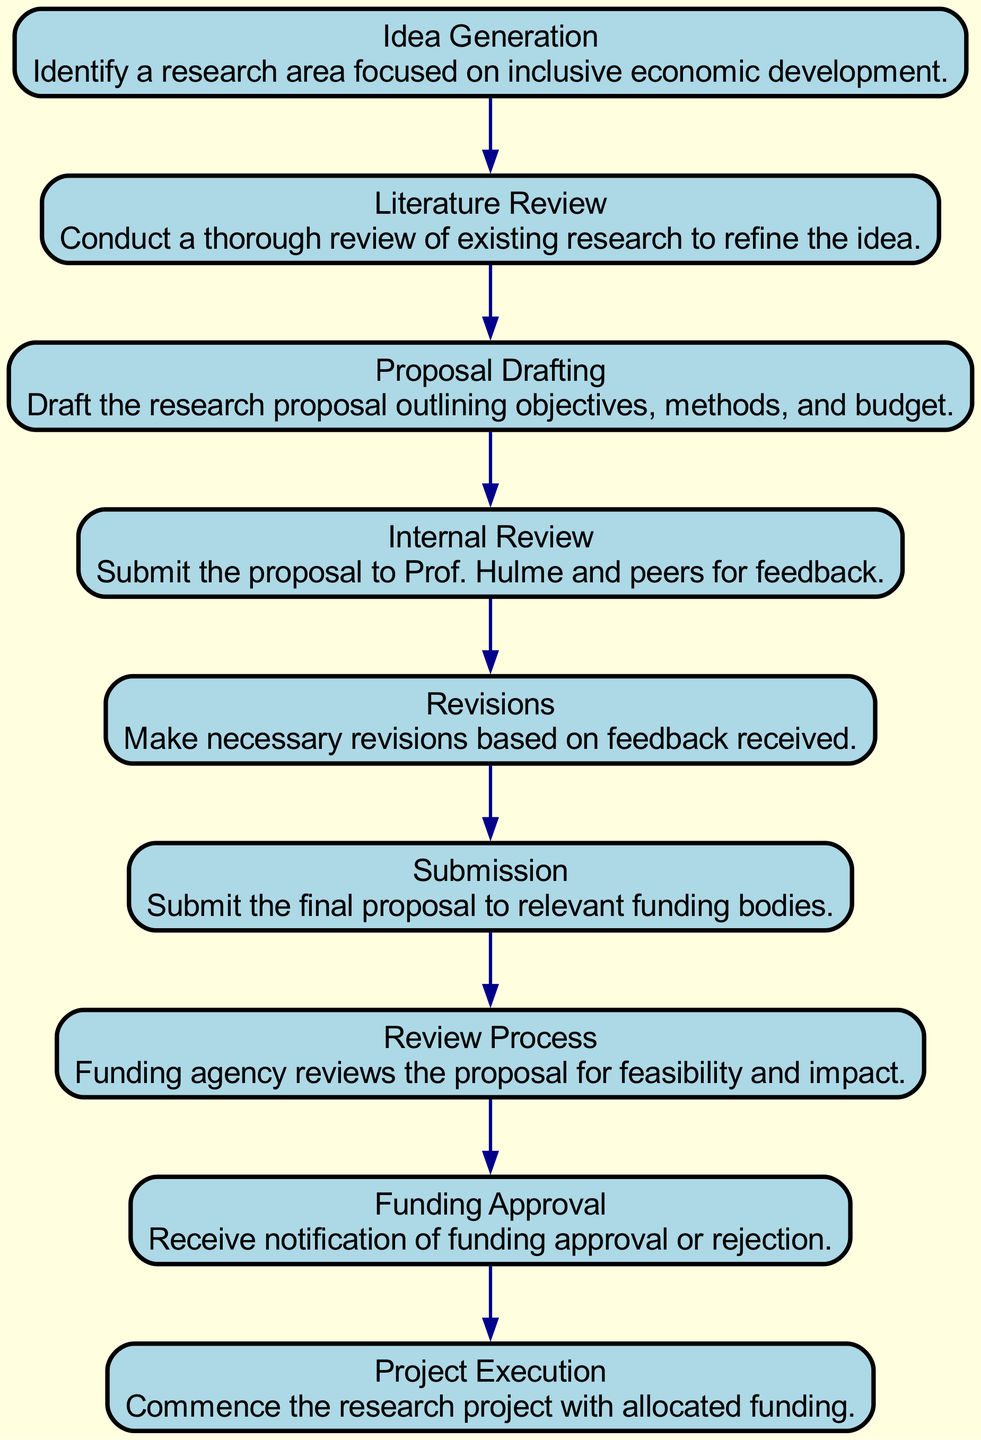What is the first step in the grant application flow? The first step in the flow is "Idea Generation." This can be confirmed by looking at the top of the flow chart where the first node is labeled as such.
Answer: Idea Generation How many nodes are there in the diagram? Counting each distinct step or stage in the flow chart reveals there are a total of 9 nodes.
Answer: 9 What happens after the "Internal Review"? The next step after "Internal Review" is "Revisions." This follows logically in the flow as indicated by the connecting arrow leading from "Internal Review" to "Revisions."
Answer: Revisions Which node directly precedes "Submission"? The node that directly comes before "Submission" is "Revisions." This can be deduced by tracing the flow in reverse from the "Submission" node back to its predecessor.
Answer: Revisions What are the last two steps in the process? The last two steps in the grant application flow are "Review Process" and "Funding Approval." These are the two nodes at the end of the sequence as seen near the bottom of the flow chart.
Answer: Review Process, Funding Approval If a proposal is approved, what is the next stage? After "Funding Approval," the next stage is "Project Execution." This follows from the funding approval notification that allows researchers to commence their projects.
Answer: Project Execution What is the primary purpose of the "Literature Review"? The "Literature Review" serves to conduct a thorough review of existing research to refine the initial idea; this is its defined function in the flow chart.
Answer: Refine the idea Which step involves feedback from Prof. Hulme and peers? The "Internal Review" step is where the proposal is submitted to Prof. Hulme and peers for feedback. This is stated directly in the description for that node.
Answer: Internal Review 